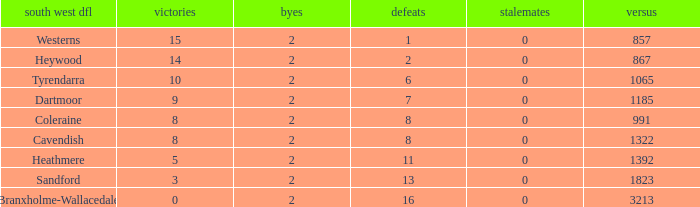How many Draws have a South West DFL of tyrendarra, and less than 10 wins? None. 